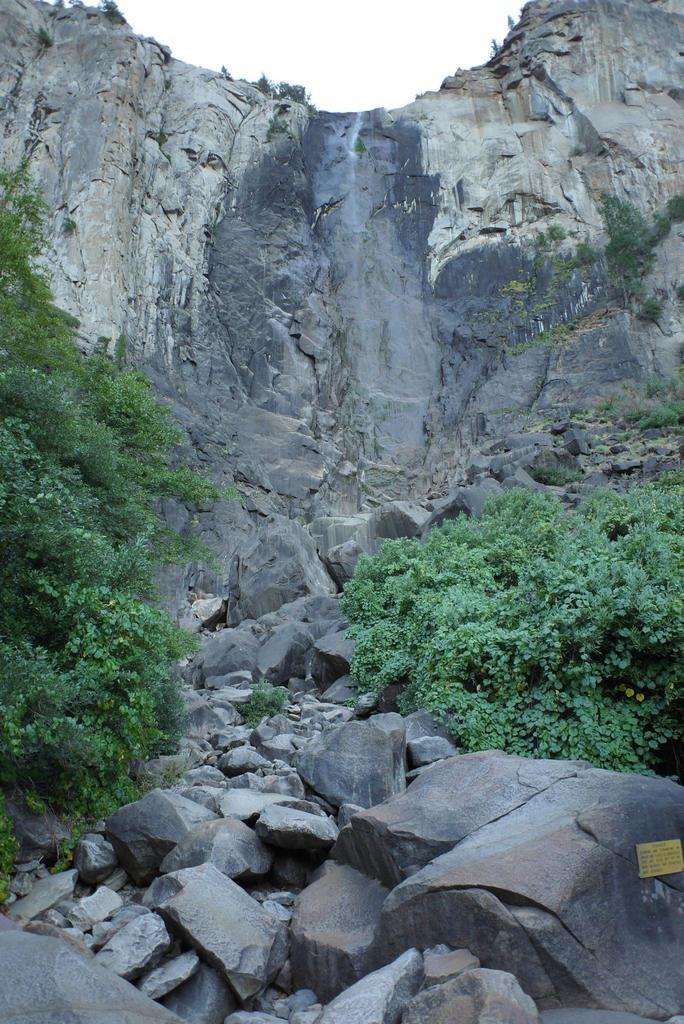Where was the picture taken? The picture was clicked outside the city. What can be seen in the foreground of the image? There are rocks and plants in the foreground of the image. What is visible in the background of the image? The sky and a mountain are visible in the background of the image. What type of game is being played on the mountain in the image? There is no game being played in the image, and the mountain is not depicted as a location for any activity. 